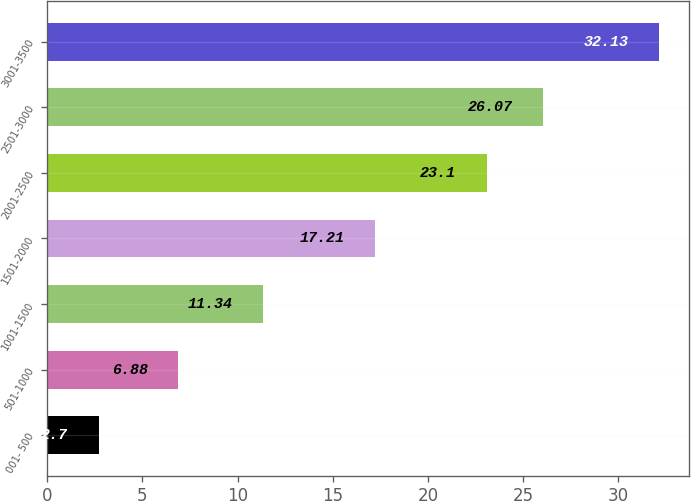<chart> <loc_0><loc_0><loc_500><loc_500><bar_chart><fcel>001- 500<fcel>501-1000<fcel>1001-1500<fcel>1501-2000<fcel>2001-2500<fcel>2501-3000<fcel>3001-3500<nl><fcel>2.7<fcel>6.88<fcel>11.34<fcel>17.21<fcel>23.1<fcel>26.07<fcel>32.13<nl></chart> 